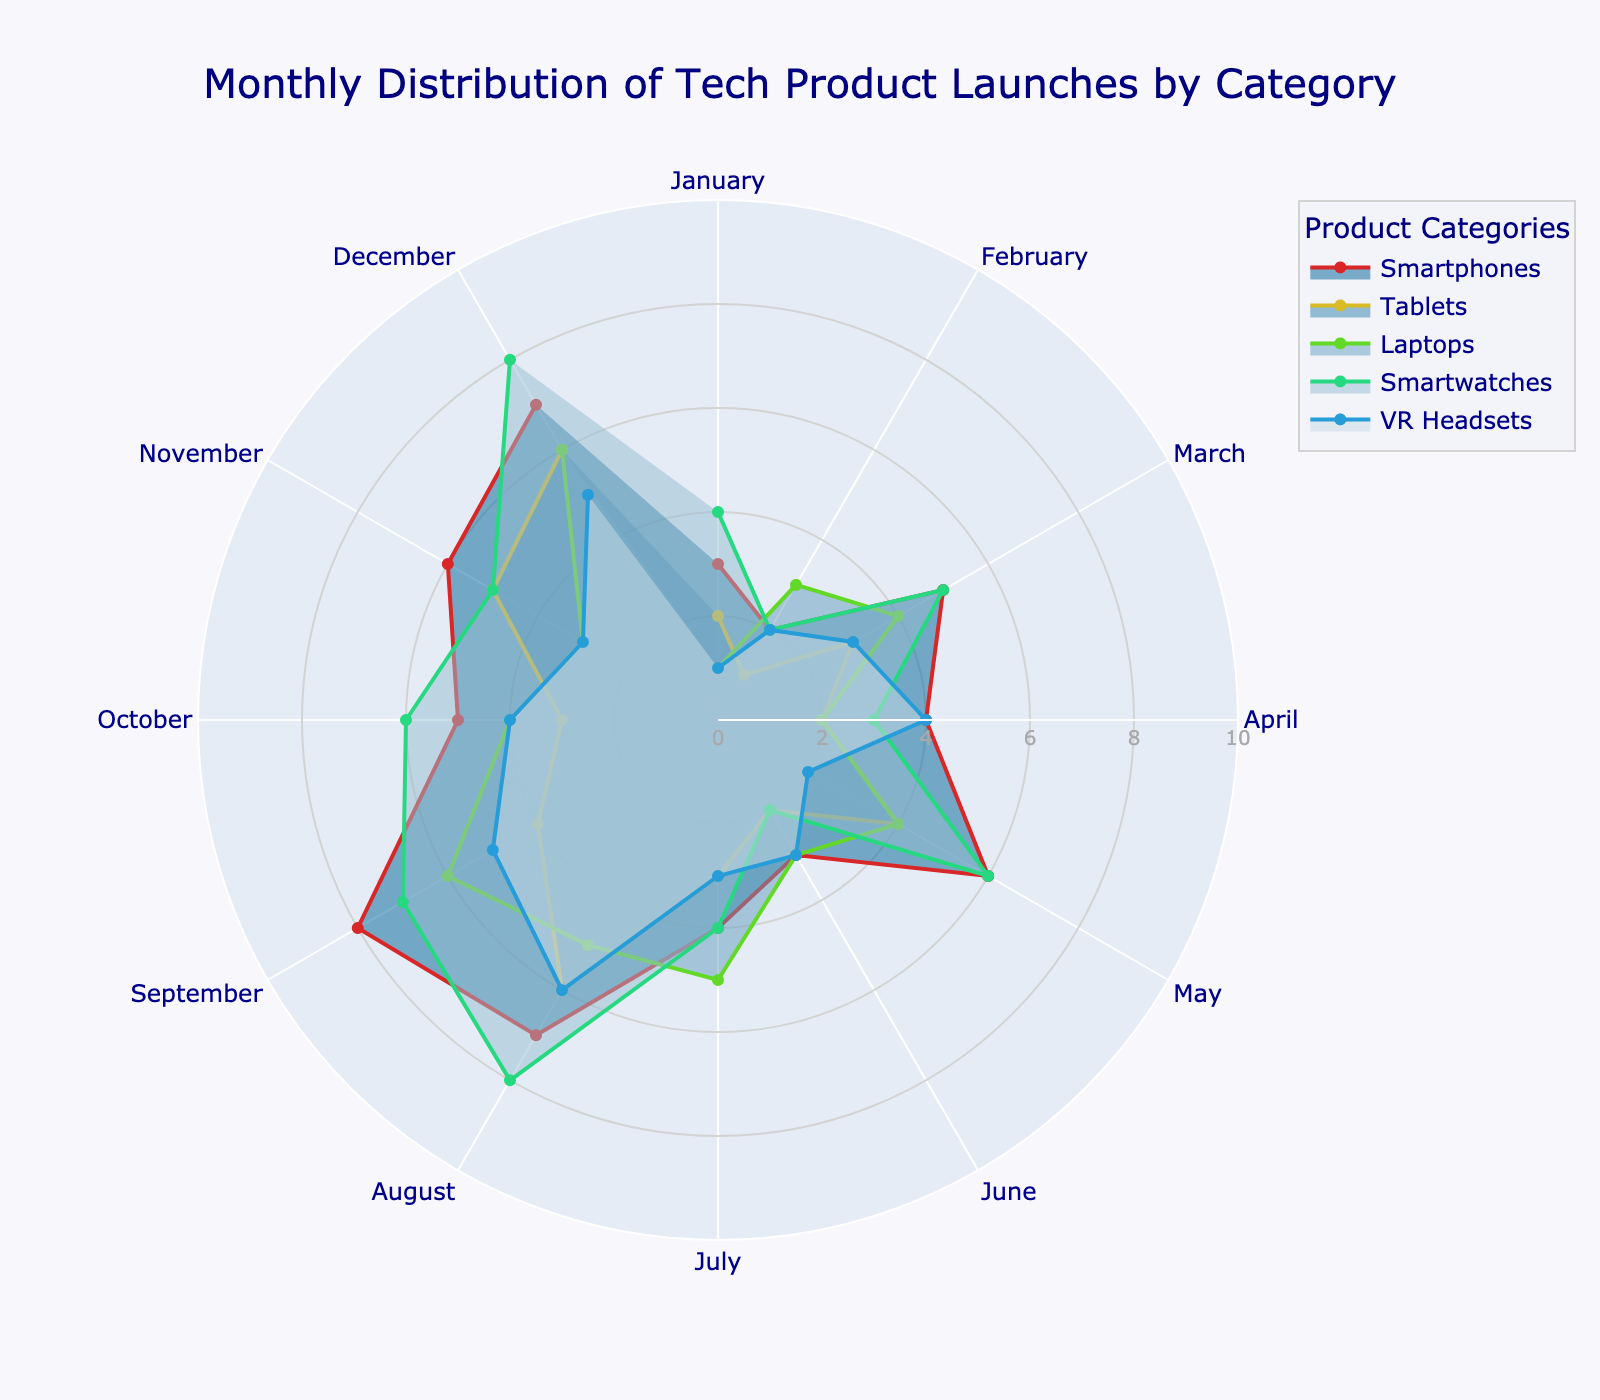What is the title of the polar area chart? The title of the chart is usually presented at the top and summarizes its content.
Answer: Monthly Distribution of Tech Product Launches by Category Which product category had the most launches in August? Identify the radial span for August within the specific category in the chart; the largest radius indicates the highest number.
Answer: Smartwatches How many months had more than 5 smartphone launches? Count the angular segments (months) where the data point for smartphones extends beyond the '5' tick on the radial axis.
Answer: 6 months What is the average number of laptop launches over the entire year? Sum the values for each month and divide by the number of months (12).
Answer: 4 Which month saw the fewest VR headsets launched? Observe the radial points for VR Headsets and identify the shortest one.
Answer: January What is the difference in the number of tablet launches between May and June? Note the radial lengths for May and June for the Tablets category and subtract the latter from the former.
Answer: 2 Which two categories had an equal number of launches in March? Identify categories whose radial lengths for March are equal.
Answer: Laptops and Smartwatches How does the number of smartwatch launches in October compare to those in July? Compare the radial lengths of the Smartwatches category for October and July.
Answer: October had 2 more launches than July What is the range of smartphone launches over the year? Find the maximum and minimum radial lengths for the Smartphones category and subtract the minimum from the maximum.
Answer: 6 In which month was the difference in the number of tech product launches between smartphones and tablets the greatest? Calculate the absolute differences in radial lengths between smartphones and tablets for each month, and find the month with the largest difference.
Answer: September 